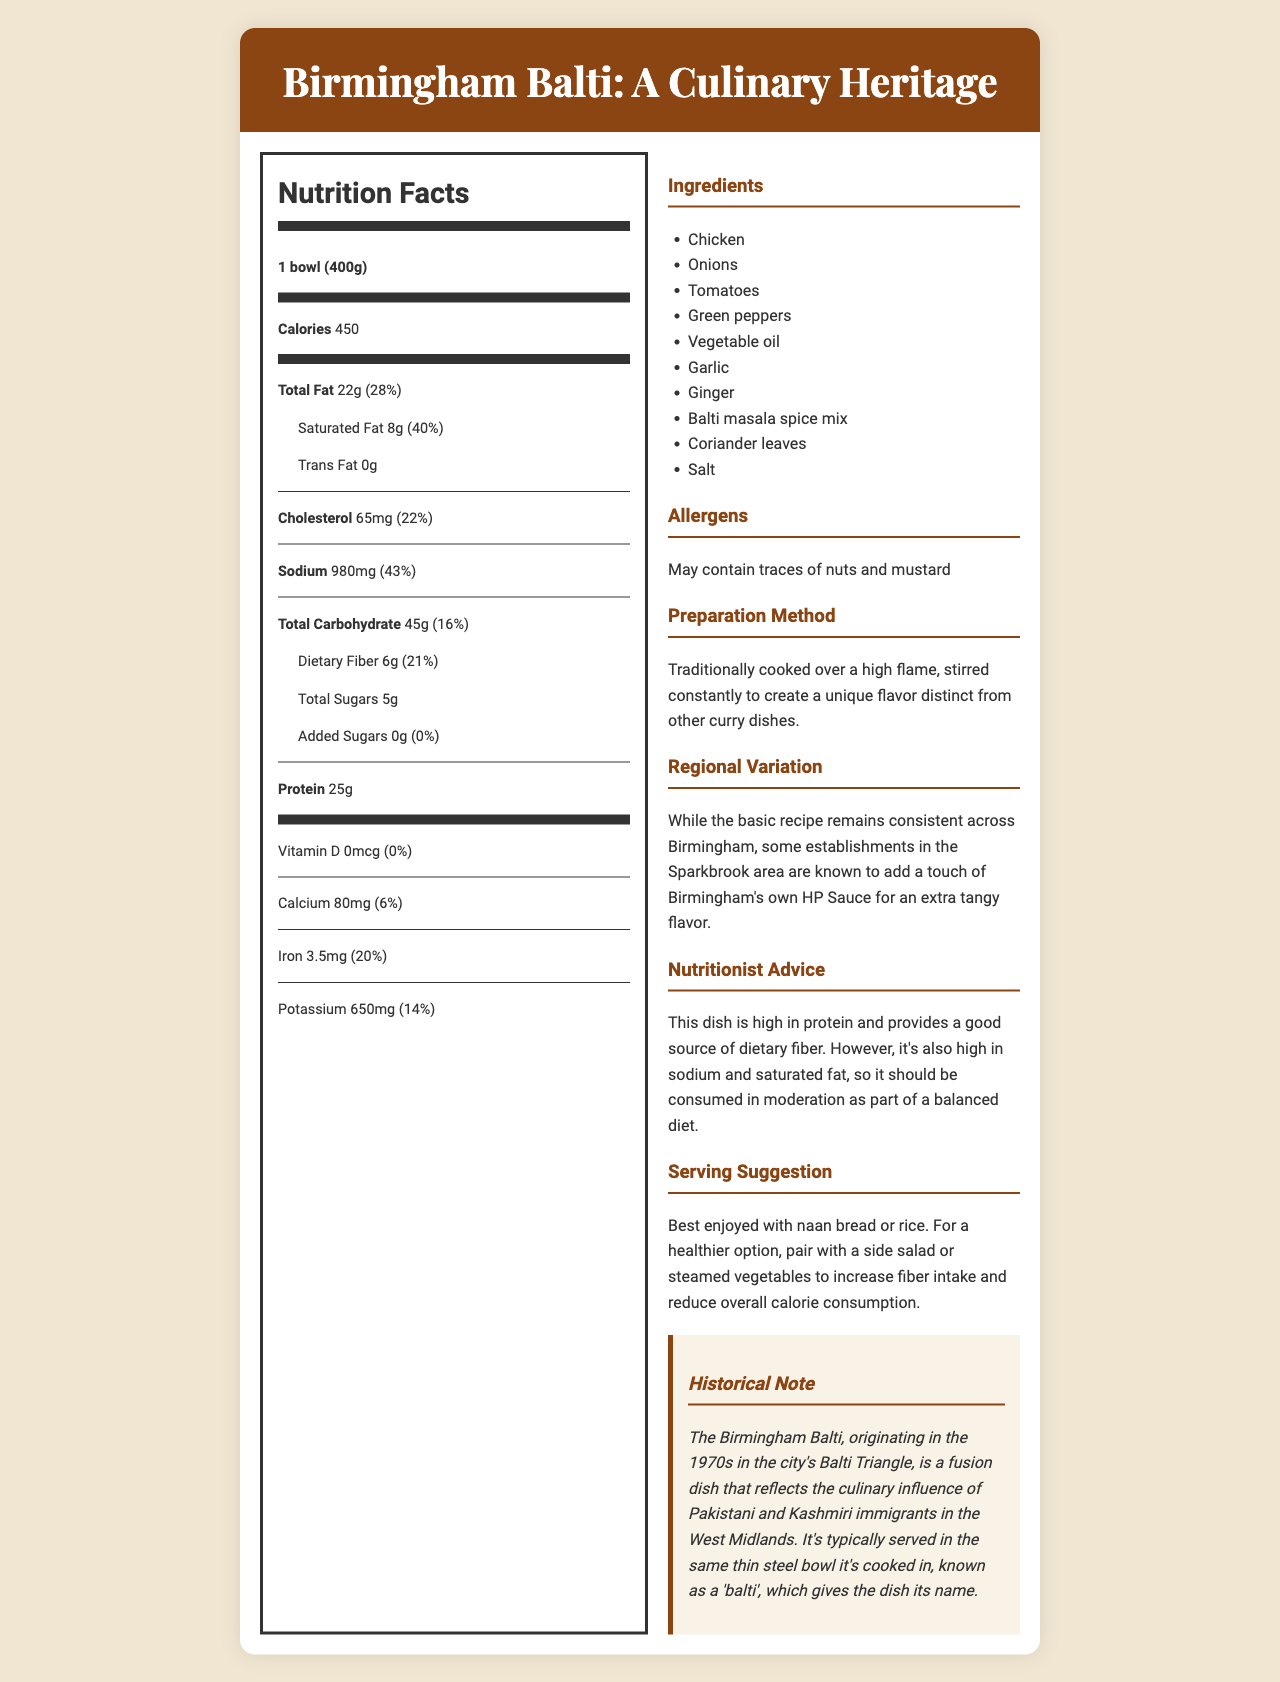what is the serving size for the Birmingham Balti dish? The serving size is specified as "1 bowl (400g)" in the Nutrition Facts section of the document.
Answer: 1 bowl (400g) how many calories are in one serving of the Birmingham Balti? The document states that there are 450 calories per serving.
Answer: 450 what percentage of the daily value of saturated fat does one serving contain? The document shows that one serving contains 40% of the daily value of saturated fat.
Answer: 40% what is the amount of dietary fiber in one serving? The document lists the dietary fiber content as 6g per serving.
Answer: 6g what cooking method is traditionally used to prepare the Birmingham Balti dish? The preparation method mentioned in the document is "Traditionally cooked over a high flame, stirred constantly."
Answer: Traditionally cooked over a high flame, stirred constantly which ingredient is not listed in the Birmingham Balti dish? A. Chicken B. Beef C. Tomatoes The ingredients listed in the document include Chicken, Onions, Tomatoes, Green peppers, Vegetable oil, Garlic, Ginger, Balti masala spice mix, Coriander leaves, and Salt. Beef is not listed.
Answer: B. Beef what is the sodium content in one serving of the Birmingham Balti dish? A. 450mg B. 980mg C. 650mg D. 390mg The document specifies that the sodium content is 980mg per serving.
Answer: B. 980mg does the Birmingham Balti dish contain any trans fat? According to the document, the dish contains 0g of trans fat.
Answer: No describe the historical significance of the Birmingham Balti dish. The historical note section of the document explains that the dish originated in the 1970s and has influences from Pakistani and Kashmiri culinary traditions, served in a unique steel bowl.
Answer: The Birmingham Balti originated in the 1970s in the city's Balti Triangle. It reflects the culinary influence of Pakistani and Kashmiri immigrants in the West Midlands and is typically served in a thin steel bowl called a 'balti.' is there any added sugar in the Birmingham Balti dish? The document indicates that the added sugars amount is 0g.
Answer: No what is the vitamin D content in one serving of the Birmingham Balti dish? The Nutrition Facts section shows that the vitamin D content is 0mcg per serving.
Answer: 0mcg how much iron is provided in one serving, in terms of the daily value percentage? The document lists the iron content as 20% of the daily value per serving.
Answer: 20% can the exact preparation time for the Birmingham Balti dish be determined from this document? The document does not provide any information regarding the preparation time needed for the dish.
Answer: Cannot be determined 